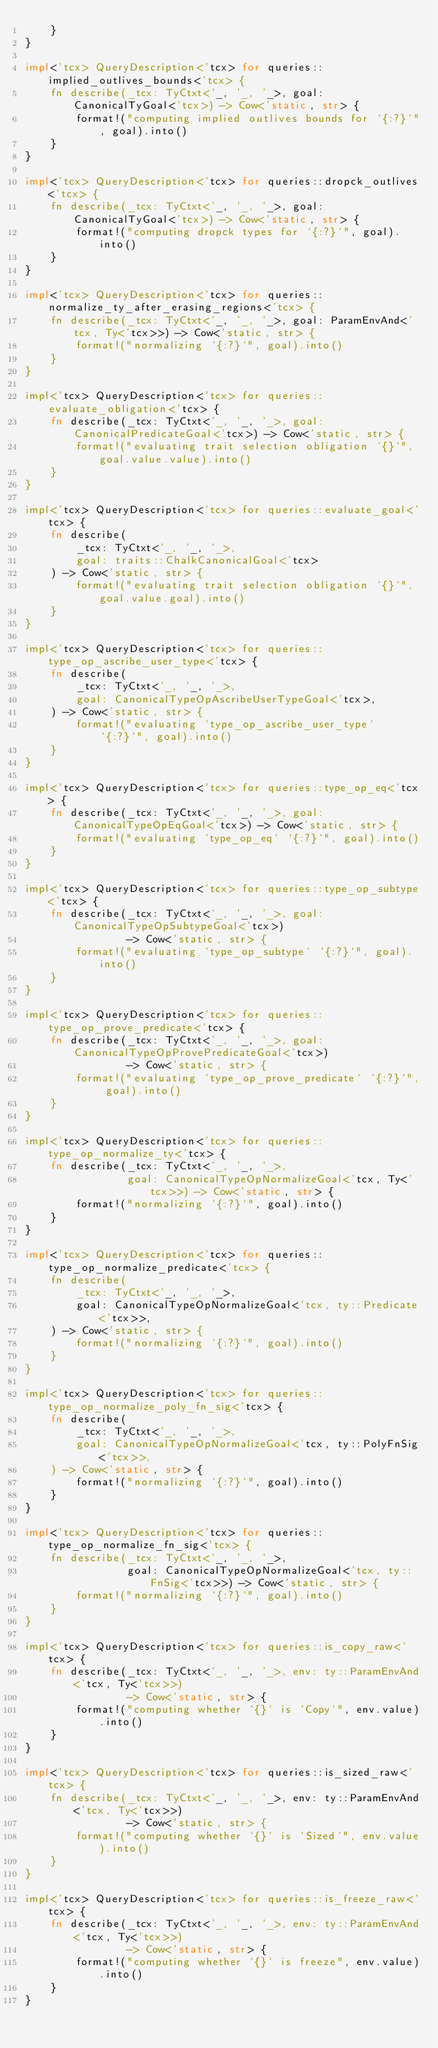Convert code to text. <code><loc_0><loc_0><loc_500><loc_500><_Rust_>    }
}

impl<'tcx> QueryDescription<'tcx> for queries::implied_outlives_bounds<'tcx> {
    fn describe(_tcx: TyCtxt<'_, '_, '_>, goal: CanonicalTyGoal<'tcx>) -> Cow<'static, str> {
        format!("computing implied outlives bounds for `{:?}`", goal).into()
    }
}

impl<'tcx> QueryDescription<'tcx> for queries::dropck_outlives<'tcx> {
    fn describe(_tcx: TyCtxt<'_, '_, '_>, goal: CanonicalTyGoal<'tcx>) -> Cow<'static, str> {
        format!("computing dropck types for `{:?}`", goal).into()
    }
}

impl<'tcx> QueryDescription<'tcx> for queries::normalize_ty_after_erasing_regions<'tcx> {
    fn describe(_tcx: TyCtxt<'_, '_, '_>, goal: ParamEnvAnd<'tcx, Ty<'tcx>>) -> Cow<'static, str> {
        format!("normalizing `{:?}`", goal).into()
    }
}

impl<'tcx> QueryDescription<'tcx> for queries::evaluate_obligation<'tcx> {
    fn describe(_tcx: TyCtxt<'_, '_, '_>, goal: CanonicalPredicateGoal<'tcx>) -> Cow<'static, str> {
        format!("evaluating trait selection obligation `{}`", goal.value.value).into()
    }
}

impl<'tcx> QueryDescription<'tcx> for queries::evaluate_goal<'tcx> {
    fn describe(
        _tcx: TyCtxt<'_, '_, '_>,
        goal: traits::ChalkCanonicalGoal<'tcx>
    ) -> Cow<'static, str> {
        format!("evaluating trait selection obligation `{}`", goal.value.goal).into()
    }
}

impl<'tcx> QueryDescription<'tcx> for queries::type_op_ascribe_user_type<'tcx> {
    fn describe(
        _tcx: TyCtxt<'_, '_, '_>,
        goal: CanonicalTypeOpAscribeUserTypeGoal<'tcx>,
    ) -> Cow<'static, str> {
        format!("evaluating `type_op_ascribe_user_type` `{:?}`", goal).into()
    }
}

impl<'tcx> QueryDescription<'tcx> for queries::type_op_eq<'tcx> {
    fn describe(_tcx: TyCtxt<'_, '_, '_>, goal: CanonicalTypeOpEqGoal<'tcx>) -> Cow<'static, str> {
        format!("evaluating `type_op_eq` `{:?}`", goal).into()
    }
}

impl<'tcx> QueryDescription<'tcx> for queries::type_op_subtype<'tcx> {
    fn describe(_tcx: TyCtxt<'_, '_, '_>, goal: CanonicalTypeOpSubtypeGoal<'tcx>)
                -> Cow<'static, str> {
        format!("evaluating `type_op_subtype` `{:?}`", goal).into()
    }
}

impl<'tcx> QueryDescription<'tcx> for queries::type_op_prove_predicate<'tcx> {
    fn describe(_tcx: TyCtxt<'_, '_, '_>, goal: CanonicalTypeOpProvePredicateGoal<'tcx>)
                -> Cow<'static, str> {
        format!("evaluating `type_op_prove_predicate` `{:?}`", goal).into()
    }
}

impl<'tcx> QueryDescription<'tcx> for queries::type_op_normalize_ty<'tcx> {
    fn describe(_tcx: TyCtxt<'_, '_, '_>,
                goal: CanonicalTypeOpNormalizeGoal<'tcx, Ty<'tcx>>) -> Cow<'static, str> {
        format!("normalizing `{:?}`", goal).into()
    }
}

impl<'tcx> QueryDescription<'tcx> for queries::type_op_normalize_predicate<'tcx> {
    fn describe(
        _tcx: TyCtxt<'_, '_, '_>,
        goal: CanonicalTypeOpNormalizeGoal<'tcx, ty::Predicate<'tcx>>,
    ) -> Cow<'static, str> {
        format!("normalizing `{:?}`", goal).into()
    }
}

impl<'tcx> QueryDescription<'tcx> for queries::type_op_normalize_poly_fn_sig<'tcx> {
    fn describe(
        _tcx: TyCtxt<'_, '_, '_>,
        goal: CanonicalTypeOpNormalizeGoal<'tcx, ty::PolyFnSig<'tcx>>,
    ) -> Cow<'static, str> {
        format!("normalizing `{:?}`", goal).into()
    }
}

impl<'tcx> QueryDescription<'tcx> for queries::type_op_normalize_fn_sig<'tcx> {
    fn describe(_tcx: TyCtxt<'_, '_, '_>,
                goal: CanonicalTypeOpNormalizeGoal<'tcx, ty::FnSig<'tcx>>) -> Cow<'static, str> {
        format!("normalizing `{:?}`", goal).into()
    }
}

impl<'tcx> QueryDescription<'tcx> for queries::is_copy_raw<'tcx> {
    fn describe(_tcx: TyCtxt<'_, '_, '_>, env: ty::ParamEnvAnd<'tcx, Ty<'tcx>>)
                -> Cow<'static, str> {
        format!("computing whether `{}` is `Copy`", env.value).into()
    }
}

impl<'tcx> QueryDescription<'tcx> for queries::is_sized_raw<'tcx> {
    fn describe(_tcx: TyCtxt<'_, '_, '_>, env: ty::ParamEnvAnd<'tcx, Ty<'tcx>>)
                -> Cow<'static, str> {
        format!("computing whether `{}` is `Sized`", env.value).into()
    }
}

impl<'tcx> QueryDescription<'tcx> for queries::is_freeze_raw<'tcx> {
    fn describe(_tcx: TyCtxt<'_, '_, '_>, env: ty::ParamEnvAnd<'tcx, Ty<'tcx>>)
                -> Cow<'static, str> {
        format!("computing whether `{}` is freeze", env.value).into()
    }
}
</code> 